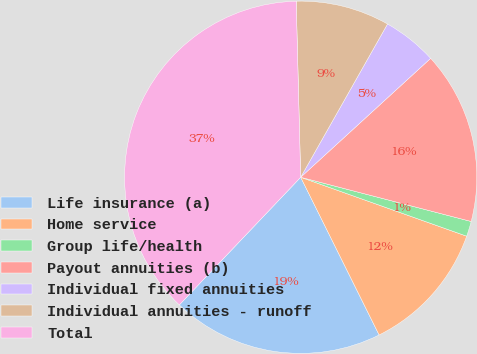<chart> <loc_0><loc_0><loc_500><loc_500><pie_chart><fcel>Life insurance (a)<fcel>Home service<fcel>Group life/health<fcel>Payout annuities (b)<fcel>Individual fixed annuities<fcel>Individual annuities - runoff<fcel>Total<nl><fcel>19.44%<fcel>12.22%<fcel>1.39%<fcel>15.83%<fcel>5.0%<fcel>8.61%<fcel>37.49%<nl></chart> 